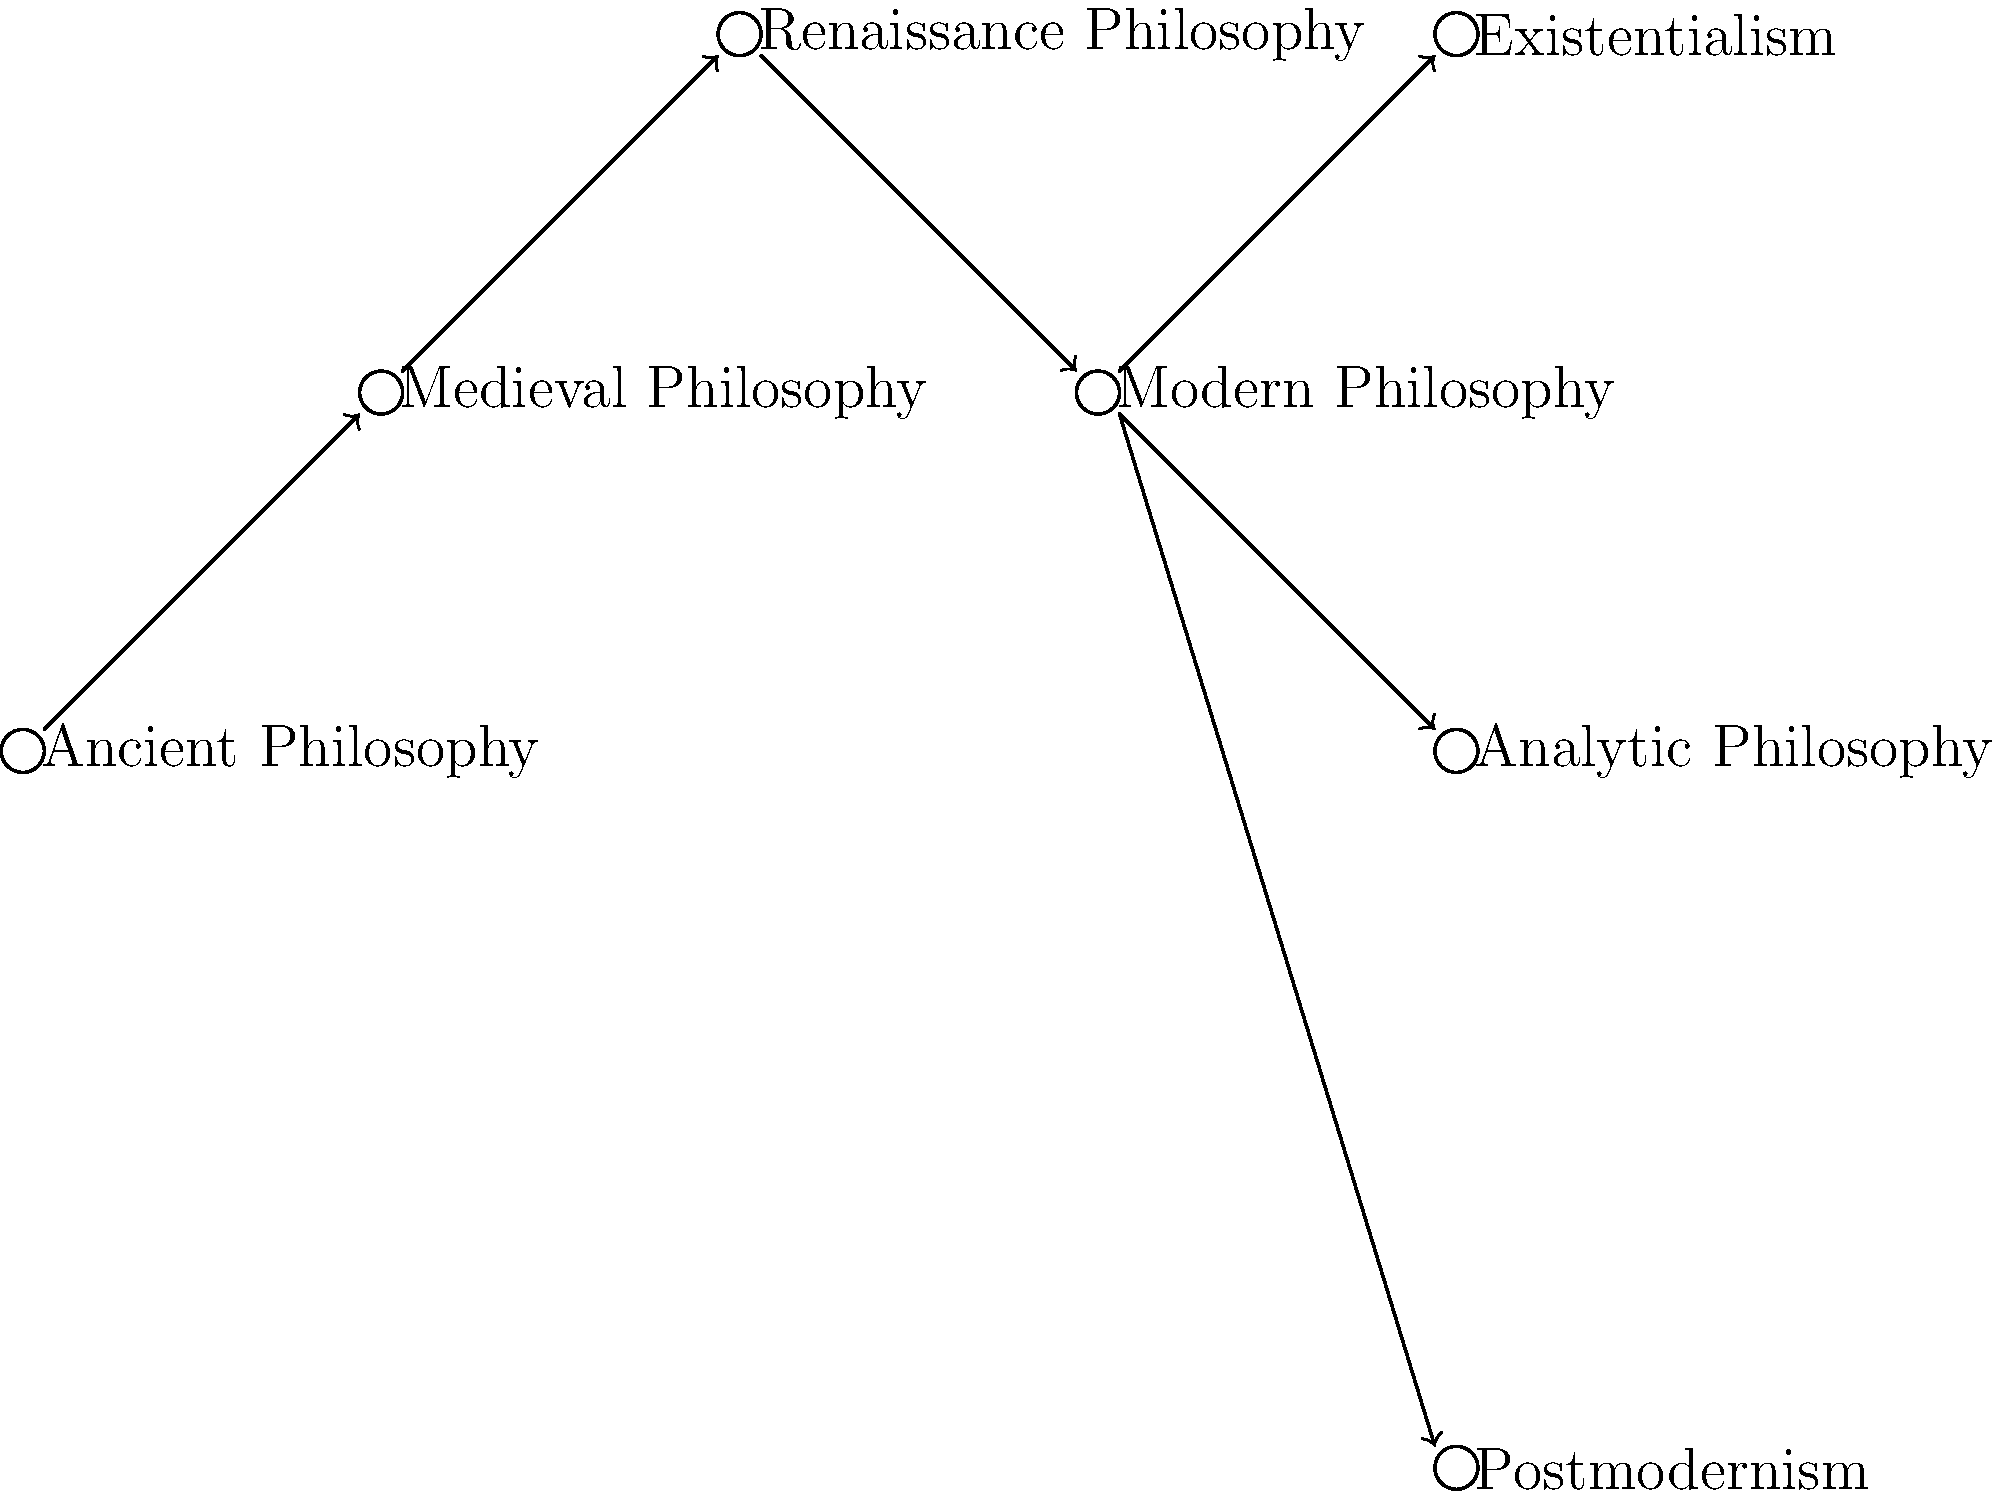Based on the philosophical timeline tree diagram, which movement directly preceded and influenced the development of Existentialism? To answer this question, we need to follow these steps:

1. Identify the position of Existentialism in the diagram.
   - Existentialism is shown at the top right of the diagram.

2. Trace back along the arrow leading to Existentialism.
   - We see that the arrow points from Modern Philosophy to Existentialism.

3. Understand the chronological order represented by the diagram.
   - The diagram shows a left-to-right progression of philosophical movements over time.

4. Recognize the direct influence implied by the arrow.
   - The arrow indicates that Modern Philosophy directly influenced and preceded Existentialism.

5. Confirm that no other movements have direct arrows to Existentialism.
   - There are no other arrows pointing directly to Existentialism from other movements.

Therefore, based on this diagram, Modern Philosophy is shown as the philosophical movement that directly preceded and influenced the development of Existentialism.
Answer: Modern Philosophy 